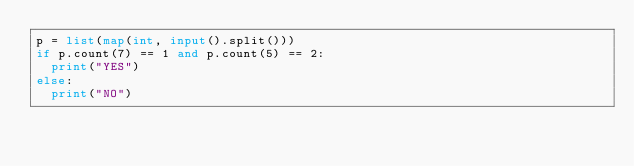<code> <loc_0><loc_0><loc_500><loc_500><_Python_>p = list(map(int, input().split()))
if p.count(7) == 1 and p.count(5) == 2:
  print("YES")
else:
  print("NO")</code> 